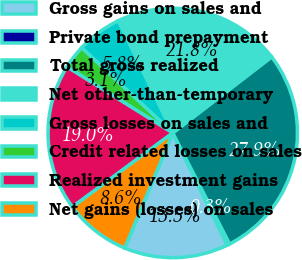Convert chart to OTSL. <chart><loc_0><loc_0><loc_500><loc_500><pie_chart><fcel>Gross gains on sales and<fcel>Private bond prepayment<fcel>Total gross realized<fcel>Net other-than-temporary<fcel>Gross losses on sales and<fcel>Credit related losses on sales<fcel>Realized investment gains<fcel>Net gains (losses) on sales<nl><fcel>13.49%<fcel>0.33%<fcel>27.9%<fcel>21.76%<fcel>5.84%<fcel>3.08%<fcel>19.0%<fcel>8.6%<nl></chart> 